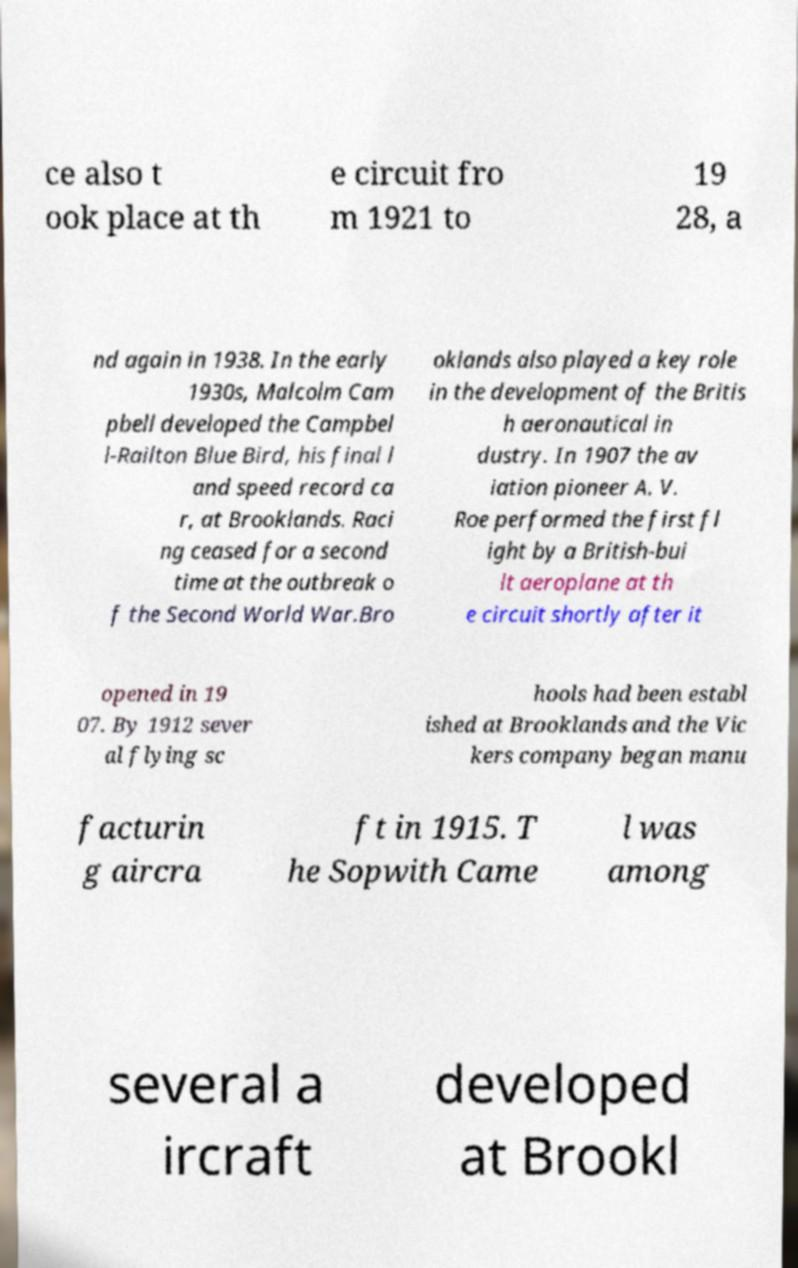Could you extract and type out the text from this image? ce also t ook place at th e circuit fro m 1921 to 19 28, a nd again in 1938. In the early 1930s, Malcolm Cam pbell developed the Campbel l-Railton Blue Bird, his final l and speed record ca r, at Brooklands. Raci ng ceased for a second time at the outbreak o f the Second World War.Bro oklands also played a key role in the development of the Britis h aeronautical in dustry. In 1907 the av iation pioneer A. V. Roe performed the first fl ight by a British-bui lt aeroplane at th e circuit shortly after it opened in 19 07. By 1912 sever al flying sc hools had been establ ished at Brooklands and the Vic kers company began manu facturin g aircra ft in 1915. T he Sopwith Came l was among several a ircraft developed at Brookl 